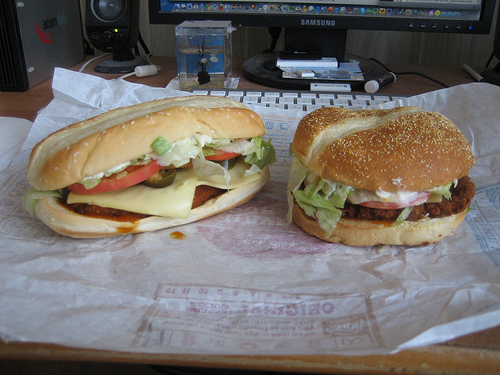Please provide the bounding box coordinate of the region this sentence describes: edge of a burn. Coordinates: [0.73, 0.56, 0.78, 0.59]. This indicates the burnt part of the food item with a slightly charred edge visible in the specified region. 